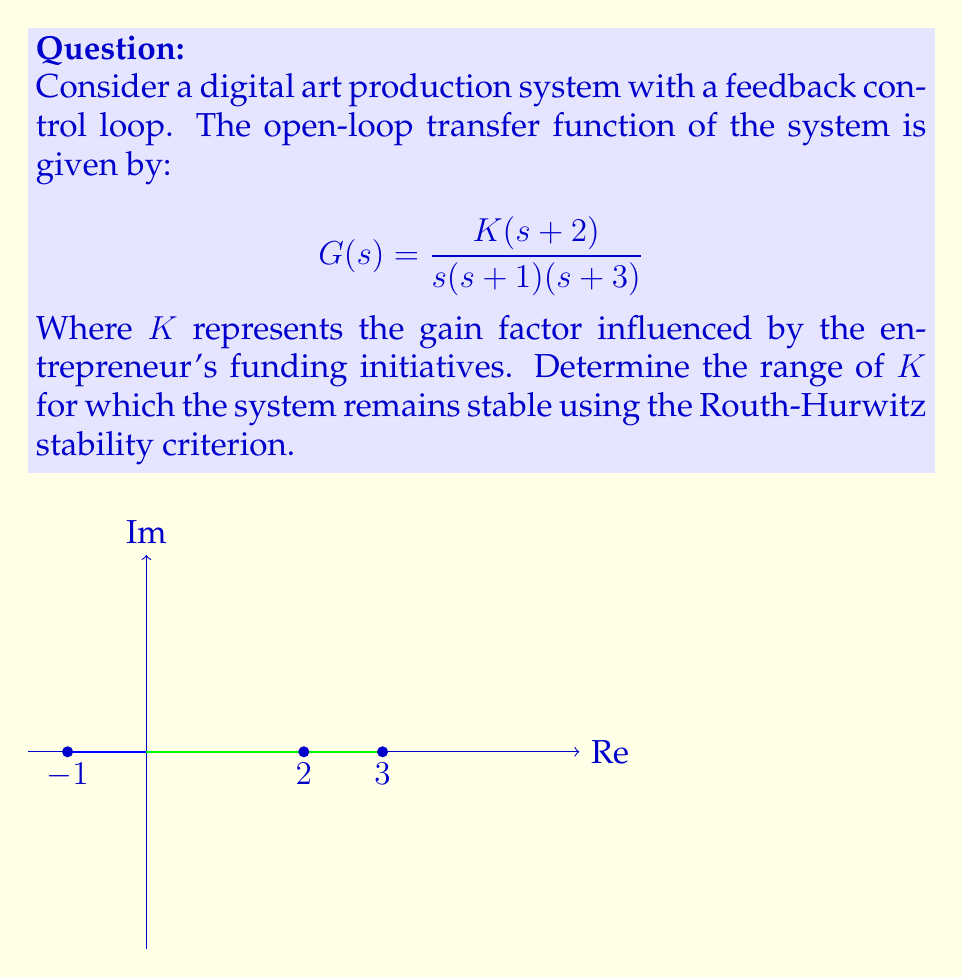Help me with this question. To determine the stability range for $K$, we'll use the Routh-Hurwitz stability criterion:

1) First, expand the characteristic equation:
   $$s(s+1)(s+3) + K(s+2) = 0$$
   $$s^3 + 4s^2 + 3s + K(s+2) = 0$$
   $$s^3 + 4s^2 + (3+K)s + 2K = 0$$

2) Construct the Routh array:
   $$\begin{array}{c|cc}
   s^3 & 1 & 3+K \\
   s^2 & 4 & 2K \\
   s^1 & \frac{12+4K-2K}{4} = 3+\frac{K}{2} & 0 \\
   s^0 & 2K & 0
   \end{array}$$

3) For stability, all elements in the first column must be positive:
   $$1 > 0 \text{ (always true)}$$
   $$4 > 0 \text{ (always true)}$$
   $$3+\frac{K}{2} > 0$$
   $$2K > 0$$

4) From the last two conditions:
   $$3+\frac{K}{2} > 0 \implies K > -6$$
   $$2K > 0 \implies K > 0$$

5) Combining these conditions, we get:
   $$K > 0$$

Therefore, the system is stable for all positive values of $K$.
Answer: $K > 0$ 